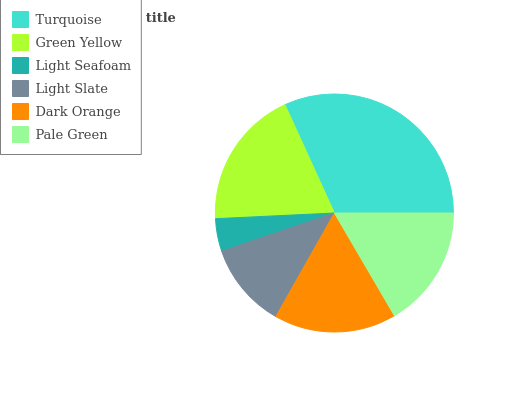Is Light Seafoam the minimum?
Answer yes or no. Yes. Is Turquoise the maximum?
Answer yes or no. Yes. Is Green Yellow the minimum?
Answer yes or no. No. Is Green Yellow the maximum?
Answer yes or no. No. Is Turquoise greater than Green Yellow?
Answer yes or no. Yes. Is Green Yellow less than Turquoise?
Answer yes or no. Yes. Is Green Yellow greater than Turquoise?
Answer yes or no. No. Is Turquoise less than Green Yellow?
Answer yes or no. No. Is Dark Orange the high median?
Answer yes or no. Yes. Is Pale Green the low median?
Answer yes or no. Yes. Is Green Yellow the high median?
Answer yes or no. No. Is Light Seafoam the low median?
Answer yes or no. No. 